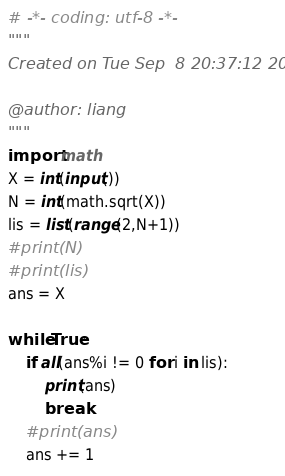Convert code to text. <code><loc_0><loc_0><loc_500><loc_500><_Python_># -*- coding: utf-8 -*-
"""
Created on Tue Sep  8 20:37:12 2020

@author: liang
"""
import math
X = int(input())
N = int(math.sqrt(X))
lis = list(range(2,N+1))
#print(N)
#print(lis)
ans = X 

while True:
    if all(ans%i != 0 for i in lis):
        print(ans)
        break
    #print(ans)
    ans += 1</code> 